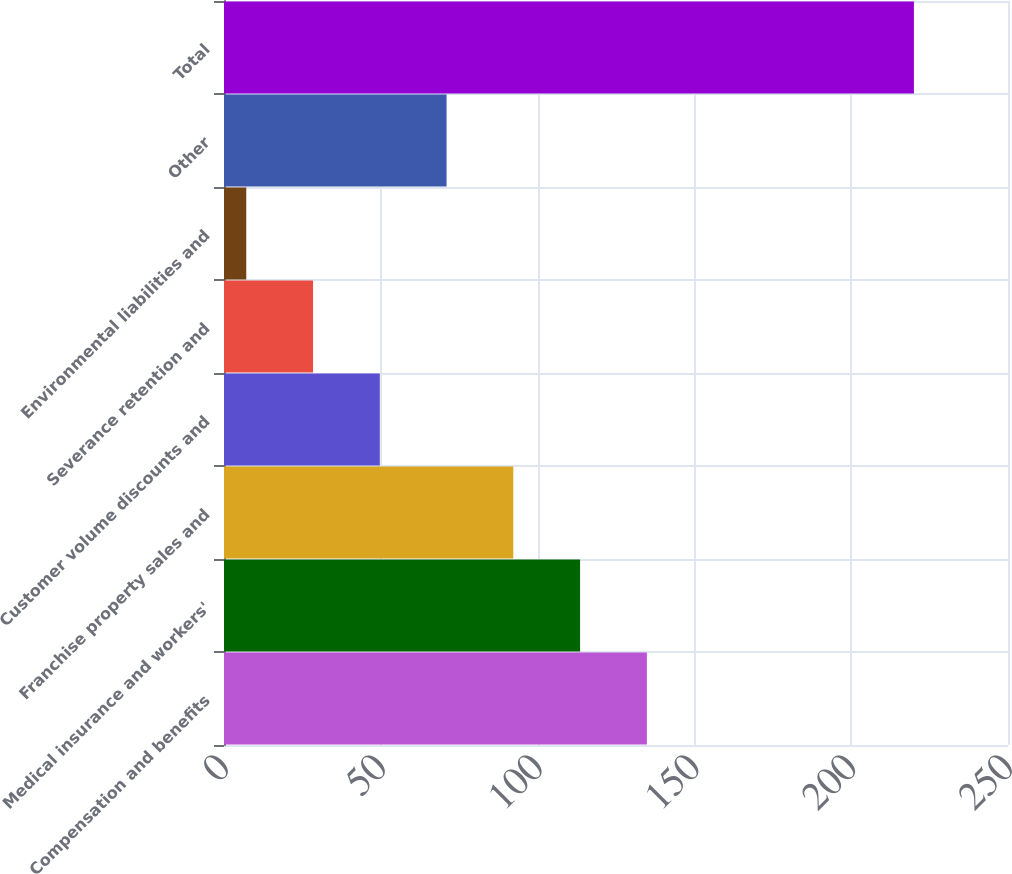<chart> <loc_0><loc_0><loc_500><loc_500><bar_chart><fcel>Compensation and benefits<fcel>Medical insurance and workers'<fcel>Franchise property sales and<fcel>Customer volume discounts and<fcel>Severance retention and<fcel>Environmental liabilities and<fcel>Other<fcel>Total<nl><fcel>134.84<fcel>113.55<fcel>92.26<fcel>49.68<fcel>28.39<fcel>7.1<fcel>70.97<fcel>220<nl></chart> 